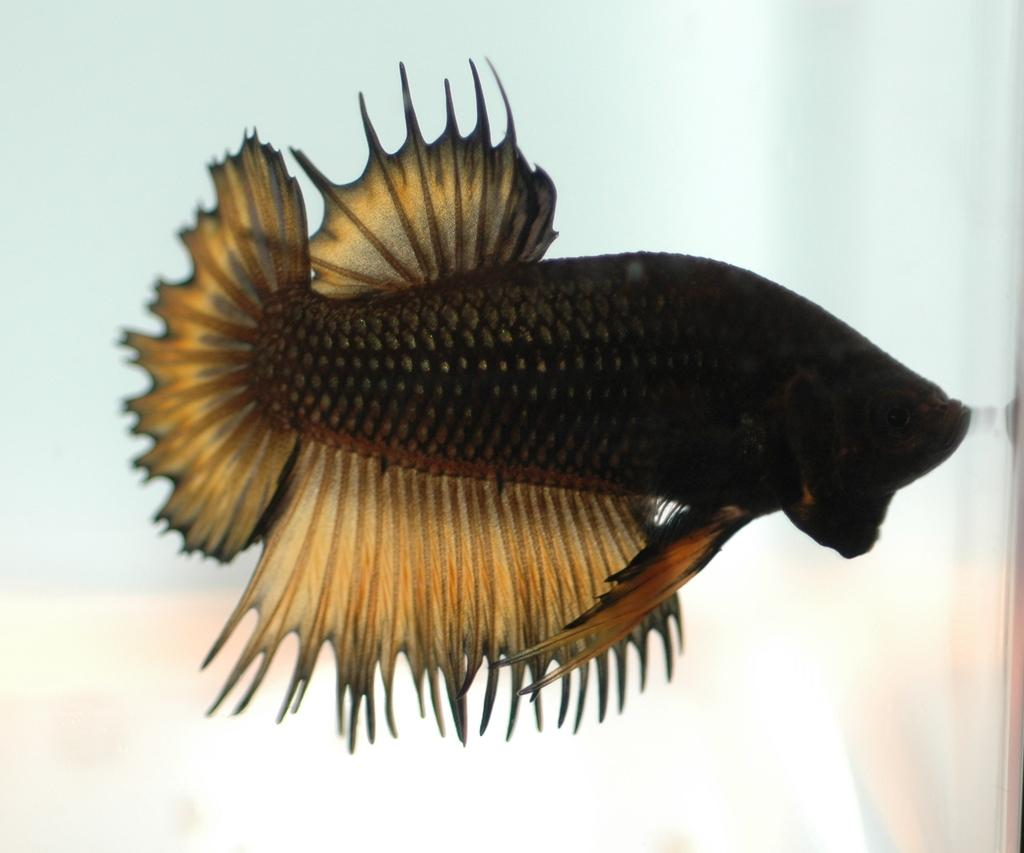What is the main subject of the image? There is a fish in the image. Can you describe the background of the image? The background of the image is blurry. How does the fish move around in the image? The fish does not move around in the image; it is a still image. What type of meat is visible in the image? There is no meat present in the image. Can you see a hand holding the fish in the image? There is no hand visible in the image. 